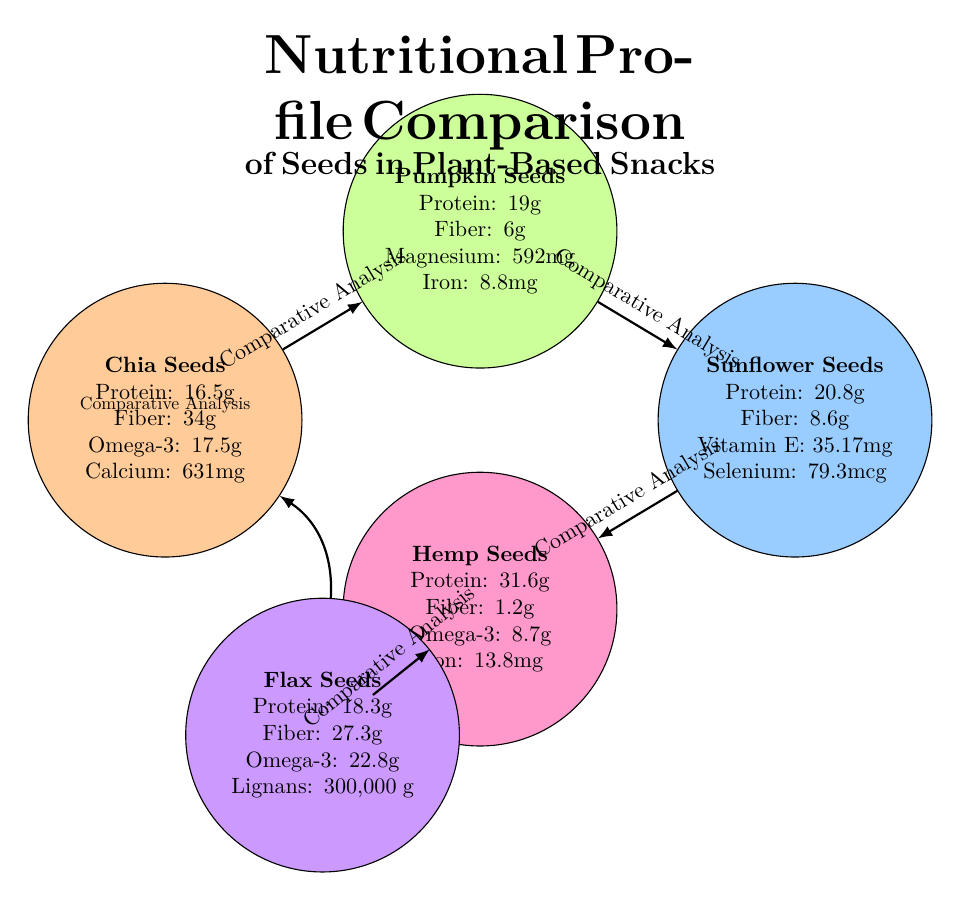What is the protein content of hemp seeds? The diagram directly lists the protein content for hemp seeds, which is 31.6g.
Answer: 31.6g Which seed has the highest fiber content? By comparing the fiber amounts provided in each seed's nutritional profile, chia seeds have 34g, which is the highest among all the seeds listed.
Answer: 34g What essential nutrient is most prevalent in flax seeds? The diagram specifies that flax seeds contain 300,000μg of lignans, indicating that this is their most notable essential nutrient.
Answer: Lignans How many seeds are compared in the diagram? The diagram features five different seed profiles, so the total number of seeds compared is five.
Answer: 5 Which seed has the least fiber content? By examining the fiber content, hemp seeds have the lowest fiber content at 1.2g compared to the others.
Answer: 1.2g What is the relationship between chia seeds and pumpkin seeds? The diagram shows an arrow labeled "Comparative Analysis" pointing from chia seeds to pumpkin seeds, indicating that they are part of a comparative study.
Answer: Comparative Analysis Which seed contains the most protein? Looking at the protein values mentioned, hemp seeds have the highest protein content at 31.6g, more than the others listed.
Answer: 31.6g How does the magnesium content of pumpkin seeds compare to iron? The diagram states pumpkin seeds have 592mg of magnesium and 8.8mg of iron; magnesium is significantly higher than iron.
Answer: Magnesium is higher Which nutrient is specific to sunflower seeds? The diagram uniquely highlights the presence of Vitamin E in sunflower seeds, indicating it as a specific nutrient for them.
Answer: Vitamin E 